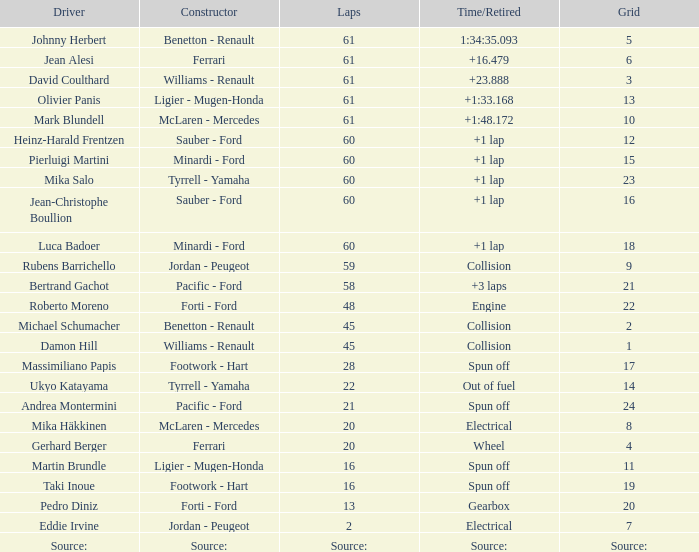What grid has 2 laps? 7.0. 